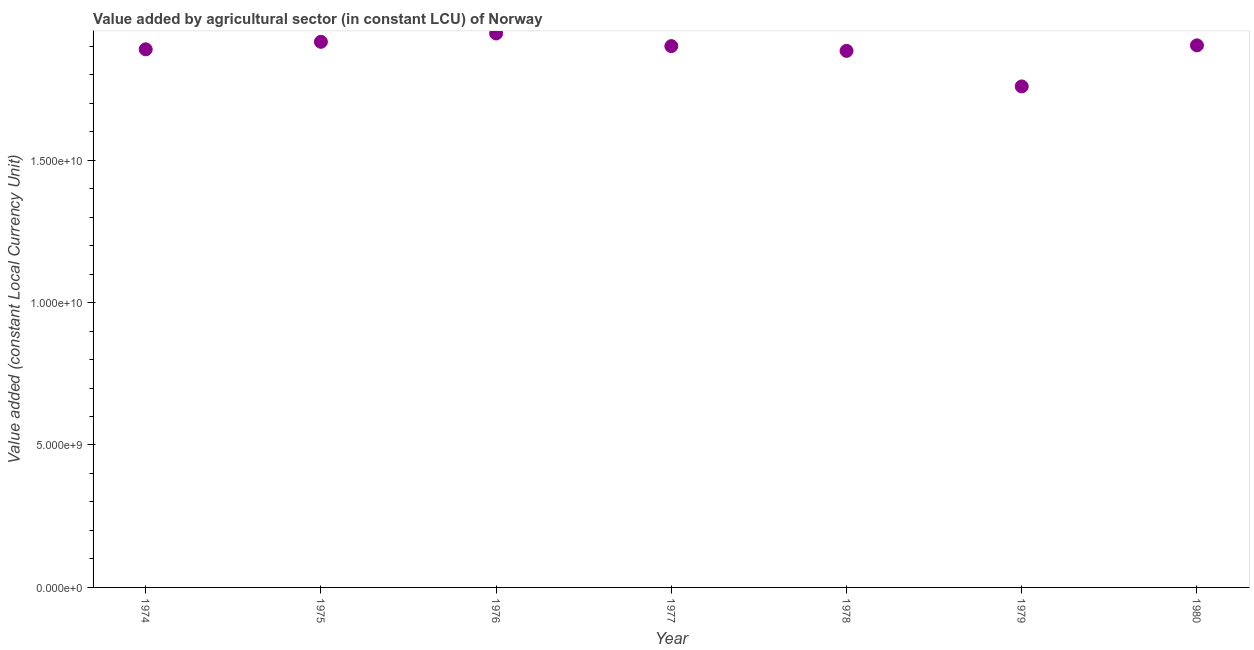What is the value added by agriculture sector in 1980?
Offer a terse response. 1.90e+1. Across all years, what is the maximum value added by agriculture sector?
Provide a short and direct response. 1.94e+1. Across all years, what is the minimum value added by agriculture sector?
Make the answer very short. 1.76e+1. In which year was the value added by agriculture sector maximum?
Make the answer very short. 1976. In which year was the value added by agriculture sector minimum?
Provide a short and direct response. 1979. What is the sum of the value added by agriculture sector?
Your response must be concise. 1.32e+11. What is the difference between the value added by agriculture sector in 1977 and 1979?
Offer a very short reply. 1.42e+09. What is the average value added by agriculture sector per year?
Provide a succinct answer. 1.88e+1. What is the median value added by agriculture sector?
Your answer should be compact. 1.90e+1. Do a majority of the years between 1980 and 1974 (inclusive) have value added by agriculture sector greater than 2000000000 LCU?
Your response must be concise. Yes. What is the ratio of the value added by agriculture sector in 1978 to that in 1980?
Keep it short and to the point. 0.99. Is the value added by agriculture sector in 1974 less than that in 1980?
Your response must be concise. Yes. Is the difference between the value added by agriculture sector in 1978 and 1980 greater than the difference between any two years?
Offer a very short reply. No. What is the difference between the highest and the second highest value added by agriculture sector?
Keep it short and to the point. 2.92e+08. What is the difference between the highest and the lowest value added by agriculture sector?
Offer a very short reply. 1.86e+09. How many dotlines are there?
Provide a succinct answer. 1. What is the difference between two consecutive major ticks on the Y-axis?
Your answer should be compact. 5.00e+09. Are the values on the major ticks of Y-axis written in scientific E-notation?
Give a very brief answer. Yes. Does the graph contain grids?
Make the answer very short. No. What is the title of the graph?
Your answer should be very brief. Value added by agricultural sector (in constant LCU) of Norway. What is the label or title of the X-axis?
Offer a terse response. Year. What is the label or title of the Y-axis?
Your answer should be very brief. Value added (constant Local Currency Unit). What is the Value added (constant Local Currency Unit) in 1974?
Offer a very short reply. 1.89e+1. What is the Value added (constant Local Currency Unit) in 1975?
Give a very brief answer. 1.92e+1. What is the Value added (constant Local Currency Unit) in 1976?
Ensure brevity in your answer.  1.94e+1. What is the Value added (constant Local Currency Unit) in 1977?
Make the answer very short. 1.90e+1. What is the Value added (constant Local Currency Unit) in 1978?
Ensure brevity in your answer.  1.88e+1. What is the Value added (constant Local Currency Unit) in 1979?
Your response must be concise. 1.76e+1. What is the Value added (constant Local Currency Unit) in 1980?
Give a very brief answer. 1.90e+1. What is the difference between the Value added (constant Local Currency Unit) in 1974 and 1975?
Offer a very short reply. -2.64e+08. What is the difference between the Value added (constant Local Currency Unit) in 1974 and 1976?
Your answer should be compact. -5.56e+08. What is the difference between the Value added (constant Local Currency Unit) in 1974 and 1977?
Provide a succinct answer. -1.12e+08. What is the difference between the Value added (constant Local Currency Unit) in 1974 and 1978?
Give a very brief answer. 5.50e+07. What is the difference between the Value added (constant Local Currency Unit) in 1974 and 1979?
Make the answer very short. 1.30e+09. What is the difference between the Value added (constant Local Currency Unit) in 1974 and 1980?
Make the answer very short. -1.39e+08. What is the difference between the Value added (constant Local Currency Unit) in 1975 and 1976?
Provide a short and direct response. -2.92e+08. What is the difference between the Value added (constant Local Currency Unit) in 1975 and 1977?
Your answer should be compact. 1.51e+08. What is the difference between the Value added (constant Local Currency Unit) in 1975 and 1978?
Provide a succinct answer. 3.19e+08. What is the difference between the Value added (constant Local Currency Unit) in 1975 and 1979?
Your answer should be compact. 1.57e+09. What is the difference between the Value added (constant Local Currency Unit) in 1975 and 1980?
Give a very brief answer. 1.25e+08. What is the difference between the Value added (constant Local Currency Unit) in 1976 and 1977?
Your response must be concise. 4.44e+08. What is the difference between the Value added (constant Local Currency Unit) in 1976 and 1978?
Provide a short and direct response. 6.11e+08. What is the difference between the Value added (constant Local Currency Unit) in 1976 and 1979?
Your response must be concise. 1.86e+09. What is the difference between the Value added (constant Local Currency Unit) in 1976 and 1980?
Offer a very short reply. 4.17e+08. What is the difference between the Value added (constant Local Currency Unit) in 1977 and 1978?
Offer a terse response. 1.67e+08. What is the difference between the Value added (constant Local Currency Unit) in 1977 and 1979?
Offer a terse response. 1.42e+09. What is the difference between the Value added (constant Local Currency Unit) in 1977 and 1980?
Give a very brief answer. -2.64e+07. What is the difference between the Value added (constant Local Currency Unit) in 1978 and 1979?
Keep it short and to the point. 1.25e+09. What is the difference between the Value added (constant Local Currency Unit) in 1978 and 1980?
Ensure brevity in your answer.  -1.94e+08. What is the difference between the Value added (constant Local Currency Unit) in 1979 and 1980?
Provide a succinct answer. -1.44e+09. What is the ratio of the Value added (constant Local Currency Unit) in 1974 to that in 1975?
Offer a terse response. 0.99. What is the ratio of the Value added (constant Local Currency Unit) in 1974 to that in 1979?
Offer a very short reply. 1.07. What is the ratio of the Value added (constant Local Currency Unit) in 1974 to that in 1980?
Provide a succinct answer. 0.99. What is the ratio of the Value added (constant Local Currency Unit) in 1975 to that in 1976?
Provide a short and direct response. 0.98. What is the ratio of the Value added (constant Local Currency Unit) in 1975 to that in 1977?
Keep it short and to the point. 1.01. What is the ratio of the Value added (constant Local Currency Unit) in 1975 to that in 1978?
Provide a short and direct response. 1.02. What is the ratio of the Value added (constant Local Currency Unit) in 1975 to that in 1979?
Ensure brevity in your answer.  1.09. What is the ratio of the Value added (constant Local Currency Unit) in 1976 to that in 1978?
Your answer should be compact. 1.03. What is the ratio of the Value added (constant Local Currency Unit) in 1976 to that in 1979?
Make the answer very short. 1.11. What is the ratio of the Value added (constant Local Currency Unit) in 1976 to that in 1980?
Make the answer very short. 1.02. What is the ratio of the Value added (constant Local Currency Unit) in 1977 to that in 1980?
Make the answer very short. 1. What is the ratio of the Value added (constant Local Currency Unit) in 1978 to that in 1979?
Give a very brief answer. 1.07. What is the ratio of the Value added (constant Local Currency Unit) in 1978 to that in 1980?
Your answer should be compact. 0.99. What is the ratio of the Value added (constant Local Currency Unit) in 1979 to that in 1980?
Offer a terse response. 0.92. 